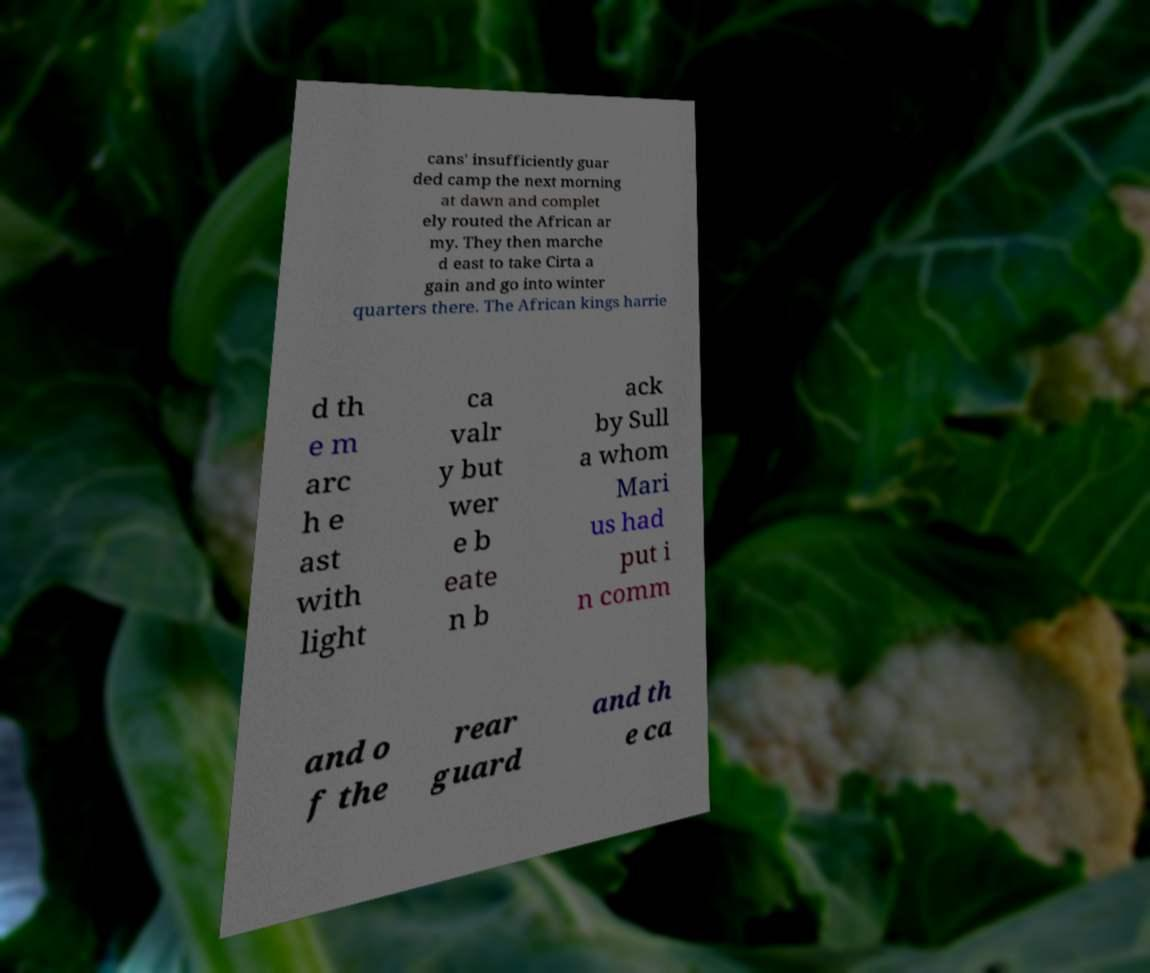Can you read and provide the text displayed in the image?This photo seems to have some interesting text. Can you extract and type it out for me? cans' insufficiently guar ded camp the next morning at dawn and complet ely routed the African ar my. They then marche d east to take Cirta a gain and go into winter quarters there. The African kings harrie d th e m arc h e ast with light ca valr y but wer e b eate n b ack by Sull a whom Mari us had put i n comm and o f the rear guard and th e ca 